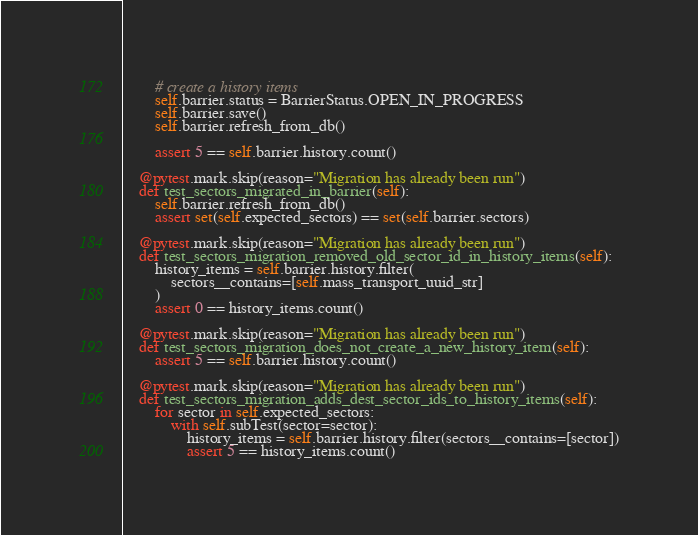<code> <loc_0><loc_0><loc_500><loc_500><_Python_>
        # create a history items
        self.barrier.status = BarrierStatus.OPEN_IN_PROGRESS
        self.barrier.save()
        self.barrier.refresh_from_db()

        assert 5 == self.barrier.history.count()

    @pytest.mark.skip(reason="Migration has already been run")
    def test_sectors_migrated_in_barrier(self):
        self.barrier.refresh_from_db()
        assert set(self.expected_sectors) == set(self.barrier.sectors)

    @pytest.mark.skip(reason="Migration has already been run")
    def test_sectors_migration_removed_old_sector_id_in_history_items(self):
        history_items = self.barrier.history.filter(
            sectors__contains=[self.mass_transport_uuid_str]
        )
        assert 0 == history_items.count()

    @pytest.mark.skip(reason="Migration has already been run")
    def test_sectors_migration_does_not_create_a_new_history_item(self):
        assert 5 == self.barrier.history.count()

    @pytest.mark.skip(reason="Migration has already been run")
    def test_sectors_migration_adds_dest_sector_ids_to_history_items(self):
        for sector in self.expected_sectors:
            with self.subTest(sector=sector):
                history_items = self.barrier.history.filter(sectors__contains=[sector])
                assert 5 == history_items.count()
</code> 